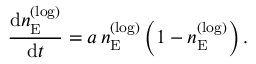<formula> <loc_0><loc_0><loc_500><loc_500>\frac { \, { \mathrm d } n _ { E } ^ { ( \log ) } } { \, { \mathrm d } t } = a \, n _ { E } ^ { ( \log ) } \left ( 1 - n _ { E } ^ { ( \log ) } \right ) .</formula> 